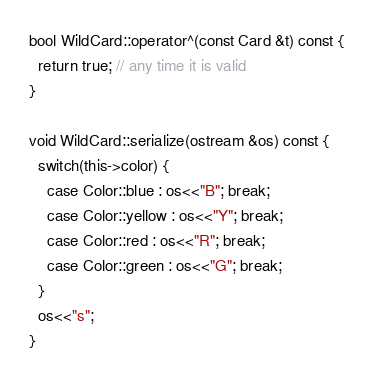Convert code to text. <code><loc_0><loc_0><loc_500><loc_500><_C++_>
bool WildCard::operator^(const Card &t) const {
  return true; // any time it is valid
}

void WildCard::serialize(ostream &os) const {
  switch(this->color) {
    case Color::blue : os<<"B"; break;
    case Color::yellow : os<<"Y"; break;
    case Color::red : os<<"R"; break;
    case Color::green : os<<"G"; break;
  }
  os<<"s";
}
</code> 